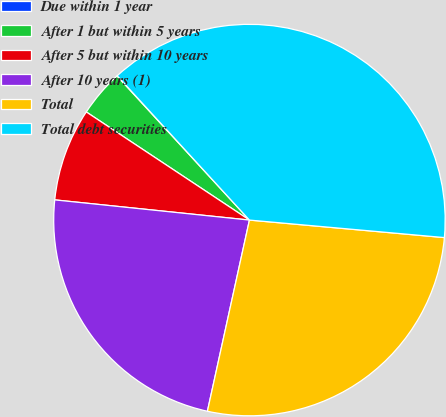Convert chart. <chart><loc_0><loc_0><loc_500><loc_500><pie_chart><fcel>Due within 1 year<fcel>After 1 but within 5 years<fcel>After 5 but within 10 years<fcel>After 10 years (1)<fcel>Total<fcel>Total debt securities<nl><fcel>0.03%<fcel>3.85%<fcel>7.67%<fcel>23.2%<fcel>27.02%<fcel>38.23%<nl></chart> 